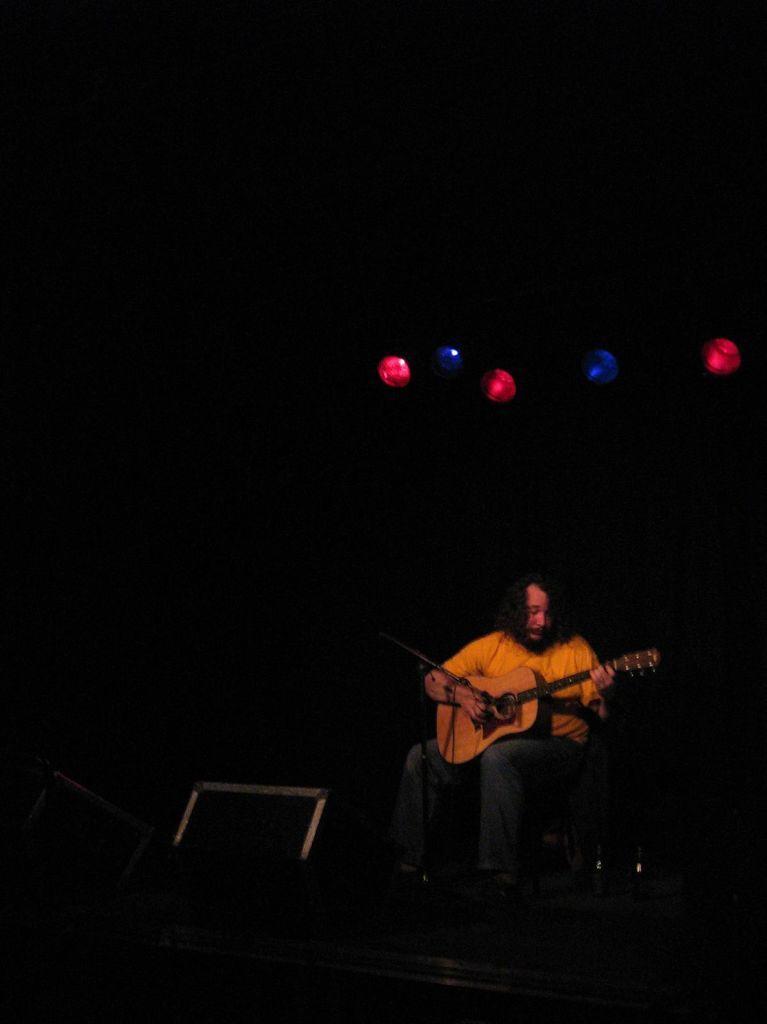In one or two sentences, can you explain what this image depicts? There is a man sitting, holding and playing guitar. In the background, there are five lights. In front him, there is a speaker and other materials. The background is in dark color. 